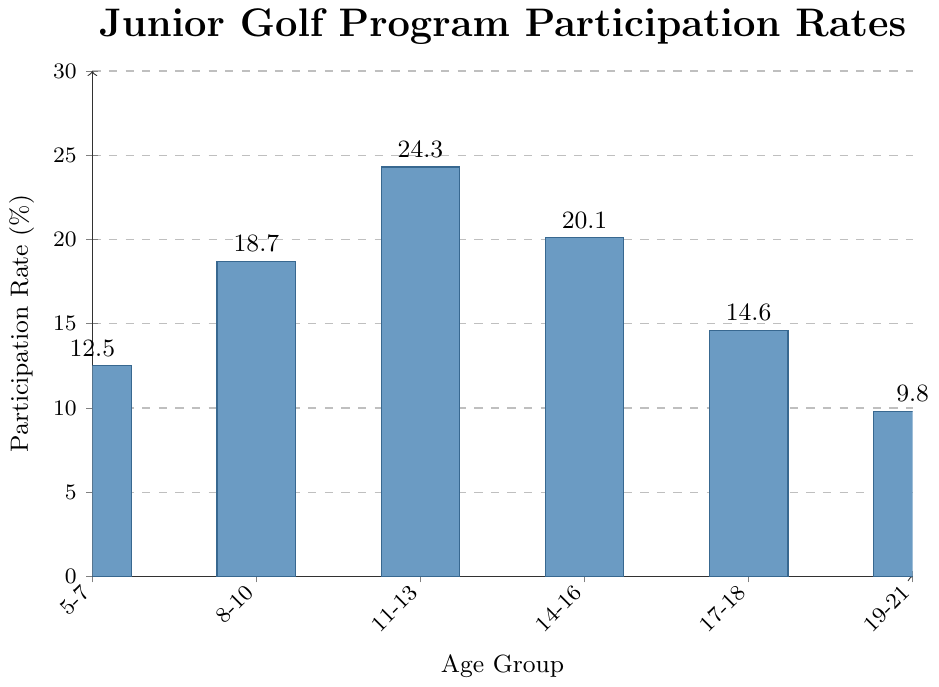What age group has the highest participation rate? The figure shows the participation rates for each age group, and the tallest bar represents the age group with the highest rate. In this case, the bar for the 11-13 years age group is the tallest, indicating the highest rate.
Answer: 11-13 years What is the combined participation rate for the age groups 5-7 years and 17-18 years? The participation rate for the 5-7 years age group is 12.5% and for the 17-18 years age group is 14.6%. Adding them together gives 12.5 + 14.6 = 27.1%.
Answer: 27.1% Which age group has a higher participation rate, 8-10 years or 14-16 years? The participation rate for 8-10 years is 18.7%, and for 14-16 years it is 20.1%. Since 20.1% is greater than 18.7%, the 14-16 years age group has a higher participation rate.
Answer: 14-16 years What is the average participation rate across all age groups? To find the average participation rate, add up all the rates (12.5 + 18.7 + 24.3 + 20.1 + 14.6 + 9.8) and divide by the number of age groups, which is 6. This gives the average as (12.5 + 18.7 + 24.3 + 20.1 + 14.6 + 9.8) / 6 = 16.667%.
Answer: 16.67% Is the participation rate for the 19-21 years age group greater than or less than the participation rate for the 8-10 years age group? The figure shows that the participation rate for the 19-21 years age group is 9.8% and for the 8-10 years age group is 18.7%. Since 9.8% is less than 18.7%, the participation rate for the 19-21 years age group is less.
Answer: Less By how much does the participation rate for the 11-13 years age group exceed the rate for the 5-7 years age group? The participation rate for the 11-13 years age group is 24.3% and for the 5-7 years age group it is 12.5%. The difference is 24.3 - 12.5 = 11.8%.
Answer: 11.8% What is the sum of the participation rates for the three youngest age groups (5-7, 8-10, 11-13)? The participation rates for these age groups are 12.5%, 18.7%, and 24.3% respectively. Adding them together gives 12.5 + 18.7 + 24.3 = 55.5%.
Answer: 55.5% Which age group has the smallest participation rate? The smallest participation rate is represented by the shortest bar on the figure. The 19-21 years age group has the shortest bar, indicating the smallest rate.
Answer: 19-21 years 